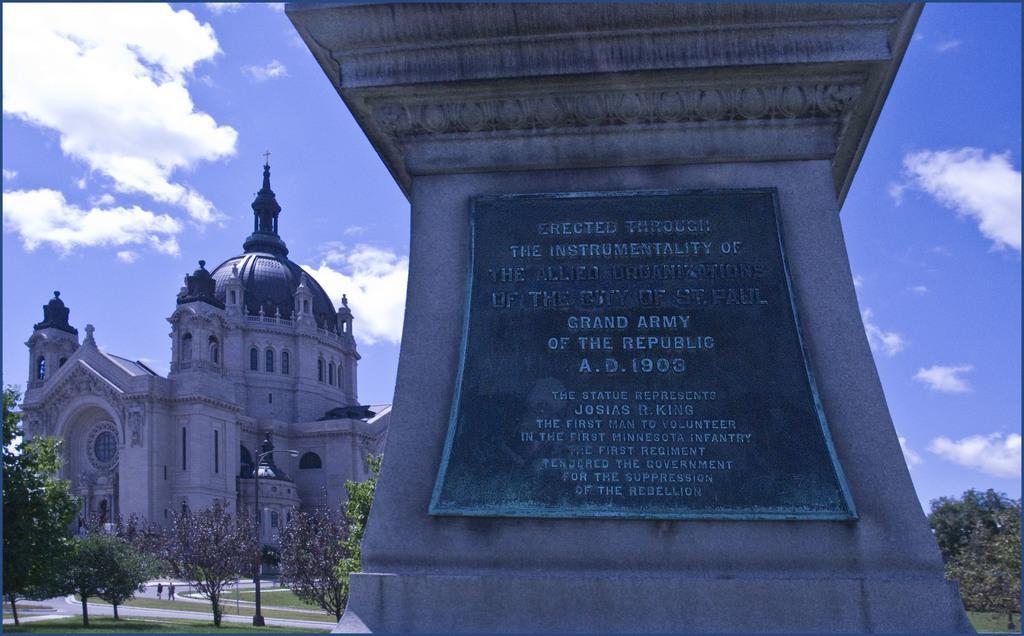Can you describe this image briefly? In this image I can see the monument. To the side of the moment I can see many trees. In the background I can see the building, clouds and the sky. 